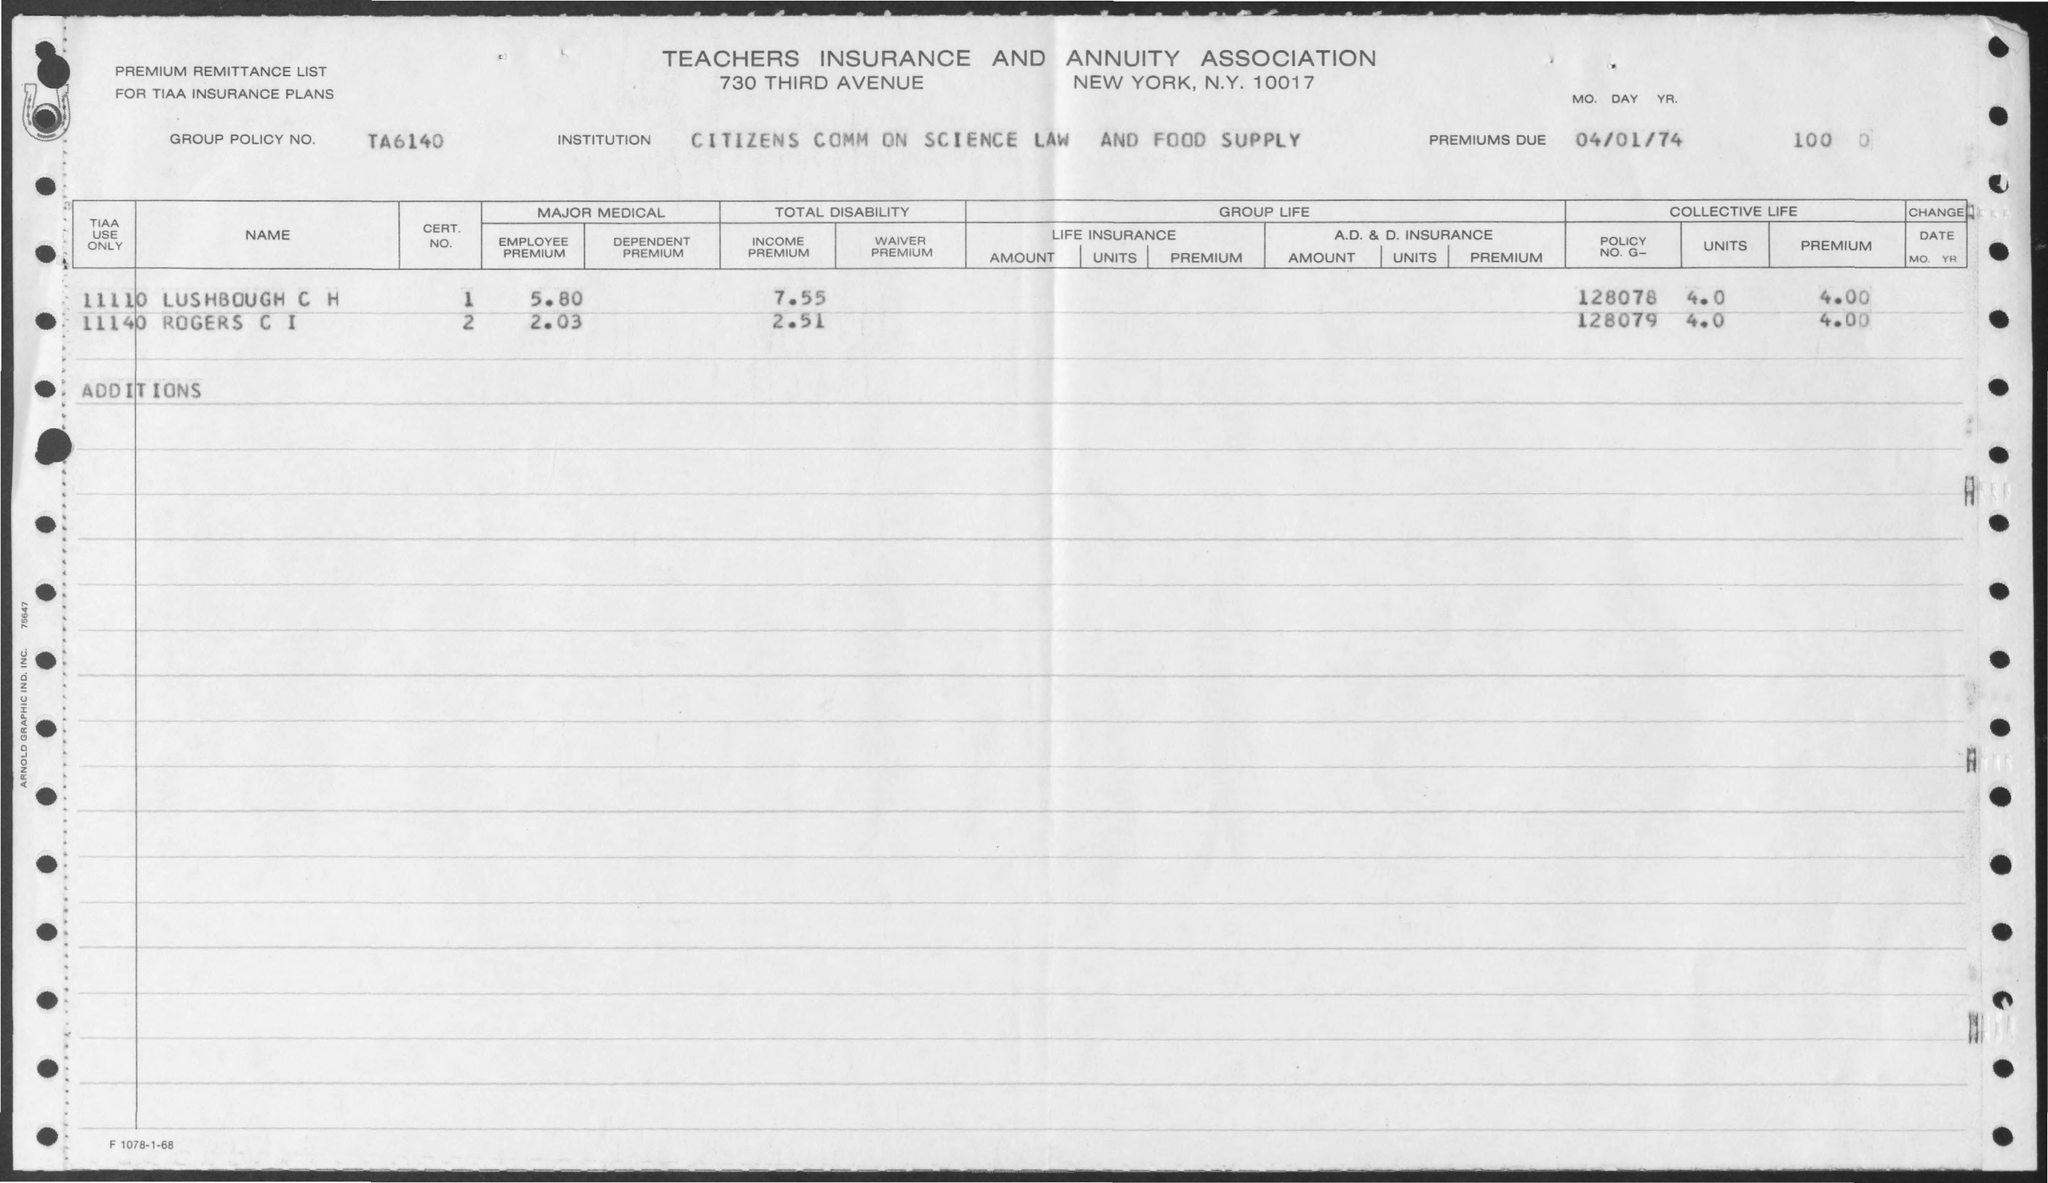What is the name of the association ?
Ensure brevity in your answer.  Teachers insurance and annuity association. What is the group policy no. mentioned in the given page ?
Make the answer very short. TA6140. What is the employee premium value for lush bough c h ?
Provide a succinct answer. 5.80. What is the income premium value for lush bough c h ?
Keep it short and to the point. 7.55. What is the employee premium value for rogers c i ?
Keep it short and to the point. 2.03. What is the income premium value for rogers c i?
Your answer should be compact. 2.51. What is the policy no. g for lush bough c h ?
Ensure brevity in your answer.  128078. What is the policy no. g for rogers c i ?
Ensure brevity in your answer.  128079. What is the premium value given for lush bough c i as given in the page ?
Keep it short and to the point. 4.00. 